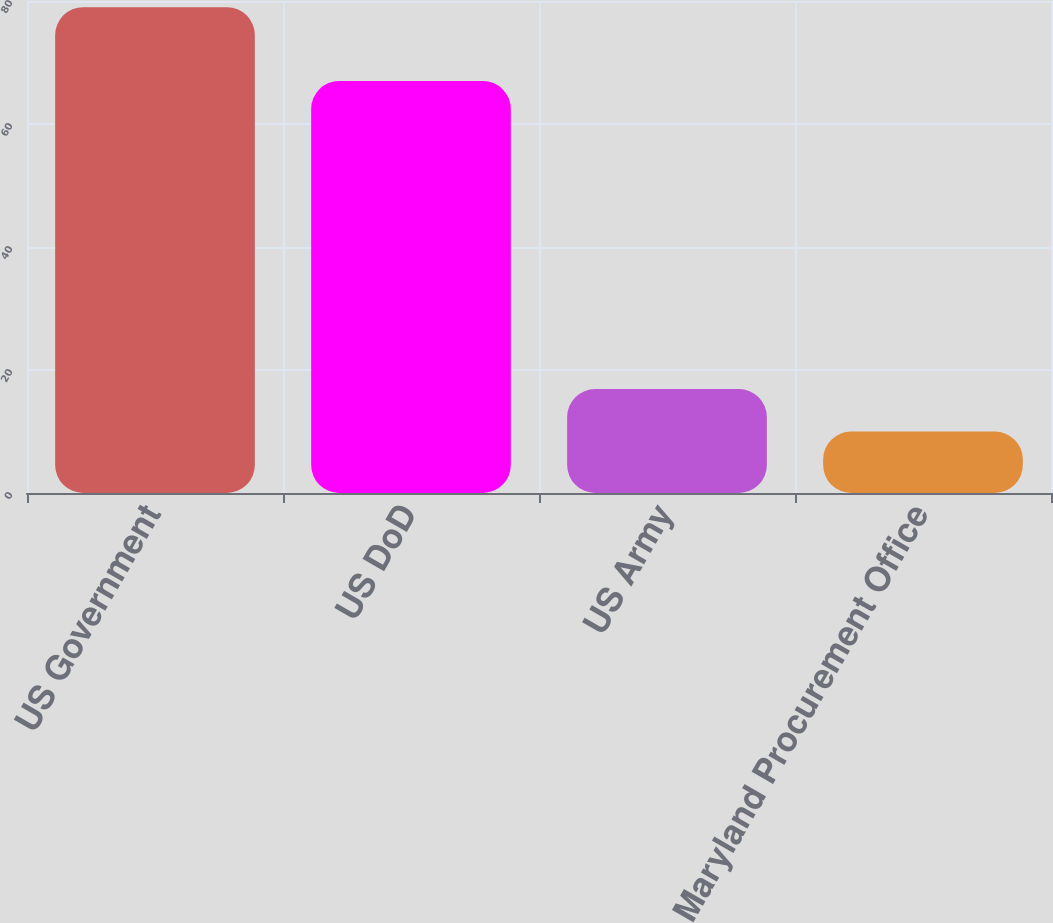<chart> <loc_0><loc_0><loc_500><loc_500><bar_chart><fcel>US Government<fcel>US DoD<fcel>US Army<fcel>Maryland Procurement Office<nl><fcel>79<fcel>67<fcel>16.9<fcel>10<nl></chart> 